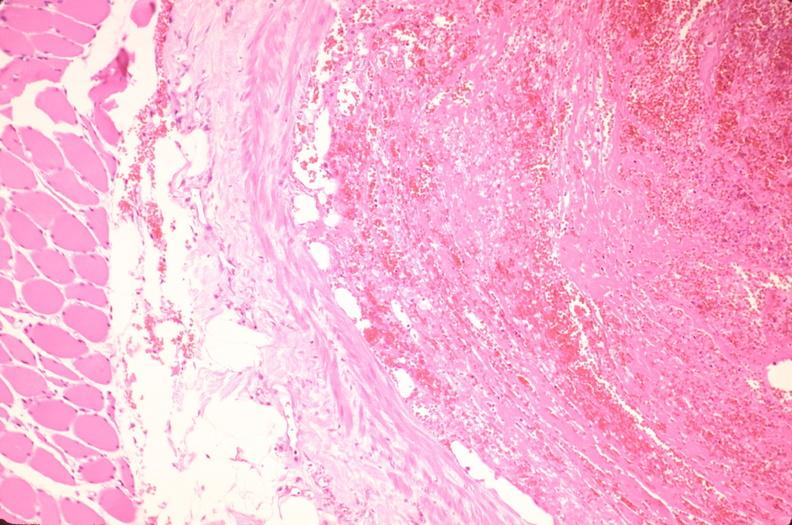what is present?
Answer the question using a single word or phrase. Vasculature 